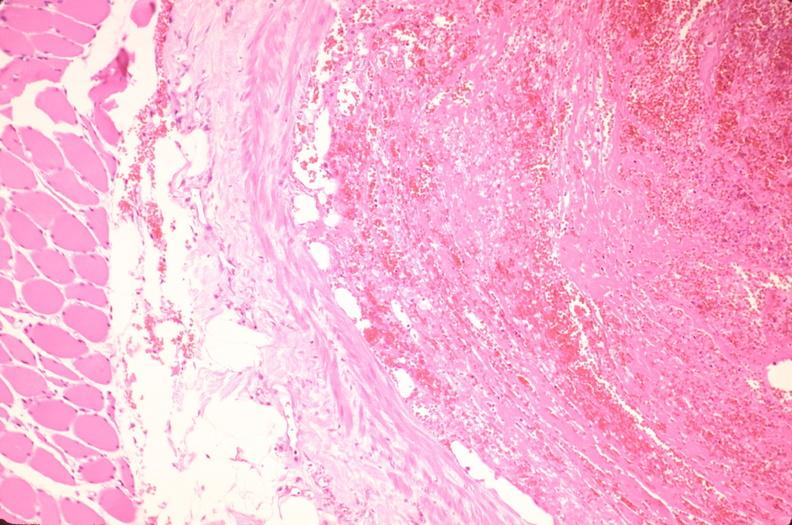what is present?
Answer the question using a single word or phrase. Vasculature 